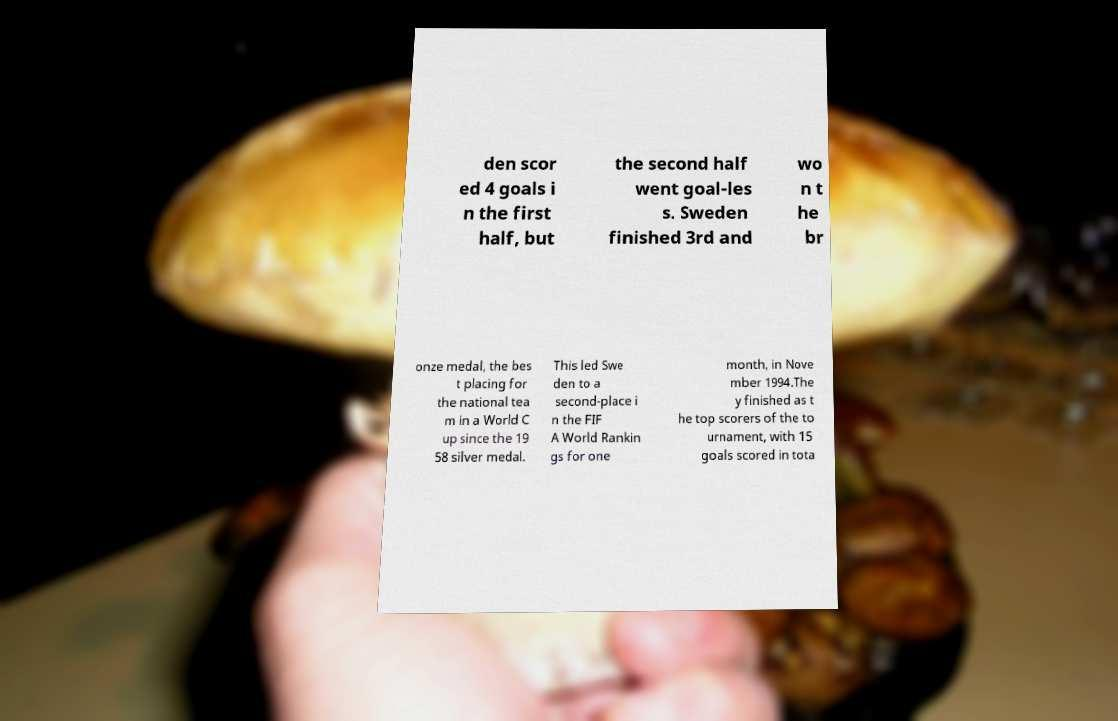For documentation purposes, I need the text within this image transcribed. Could you provide that? den scor ed 4 goals i n the first half, but the second half went goal-les s. Sweden finished 3rd and wo n t he br onze medal, the bes t placing for the national tea m in a World C up since the 19 58 silver medal. This led Swe den to a second-place i n the FIF A World Rankin gs for one month, in Nove mber 1994.The y finished as t he top scorers of the to urnament, with 15 goals scored in tota 